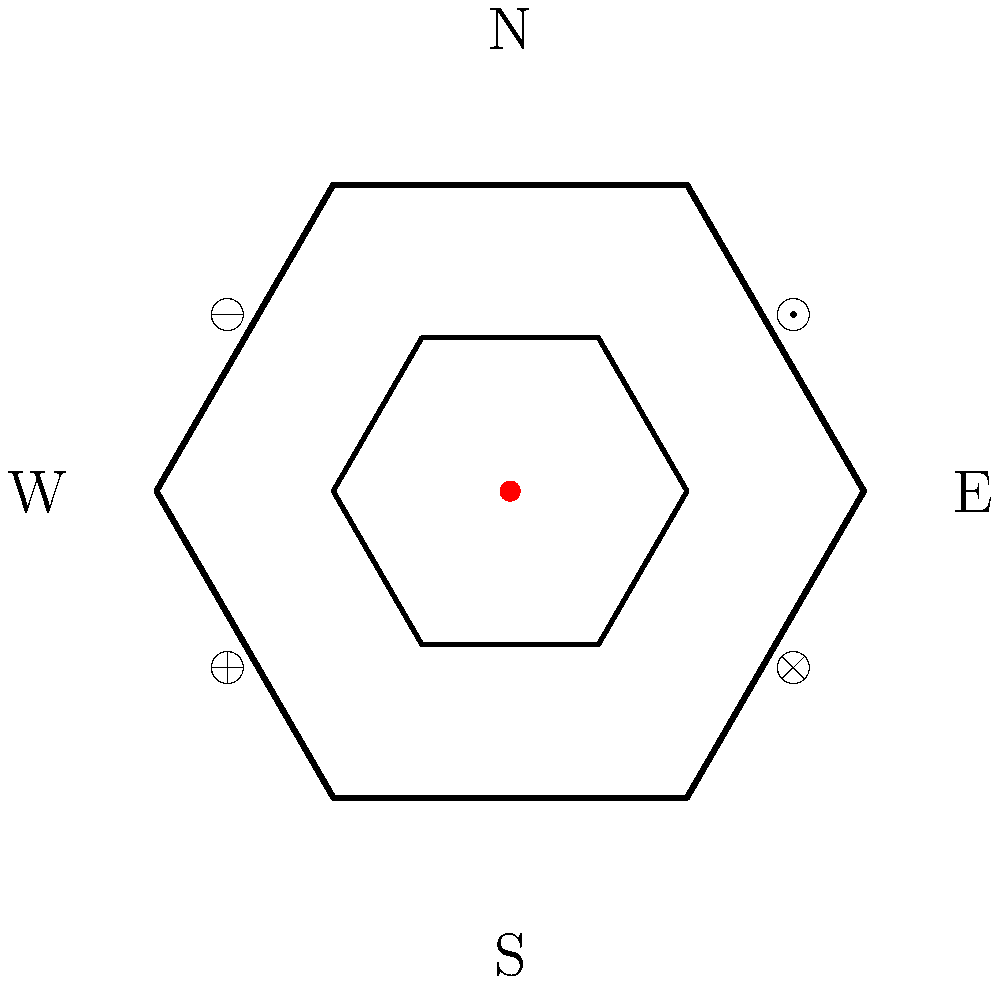Based on the floor plan of this ancient hexagonal temple, which symbolic element is likely associated with the concept of balance or equilibrium in the temple's design? To answer this question, we need to analyze the layout and symbolism present in the temple floor plan:

1. The temple has a hexagonal shape, which often represents harmony and balance in ancient architecture.

2. There is an inner chamber, also hexagonal, suggesting a sacred or central area.

3. At the center of the inner chamber is a red dot, likely representing an altar or focal point of worship.

4. Four symbols are placed symmetrically around the inner chamber:
   - $\odot$ in the northeast
   - $\oplus$ in the southwest
   - $\otimes$ in the southeast
   - $\ominus$ in the northwest

5. Among these symbols, the $\oplus$ is particularly significant in many ancient cultures:
   - It combines both vertical and horizontal lines, suggesting the intersection of heaven and earth.
   - The symbol is often associated with the four cardinal directions, representing wholeness and completeness.
   - In many esoteric traditions, it symbolizes the union of opposites or the balance of different elements.

6. The placement of $\oplus$ in the southwest, directly opposite to $\odot$ in the northeast, further emphasizes the idea of balance and complementary forces.

Given these observations, the $\oplus$ symbol is most likely associated with the concept of balance or equilibrium in the temple's design. Its shape and positioning within the symmetrical layout of the temple support this interpretation.
Answer: $\oplus$ symbol 